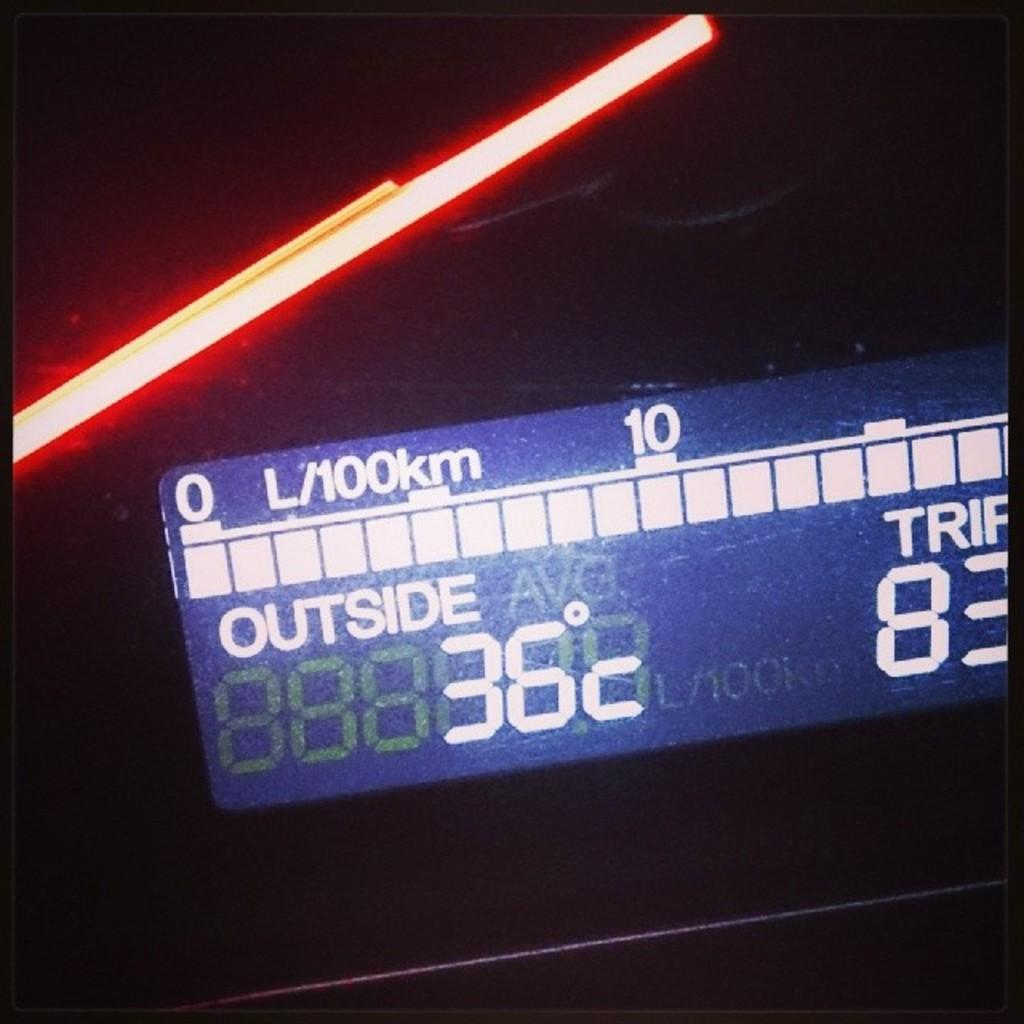Provide a one-sentence caption for the provided image. A screen displays the outside temperature of 36 degrees C. 